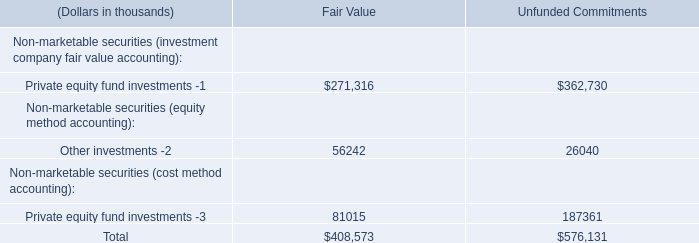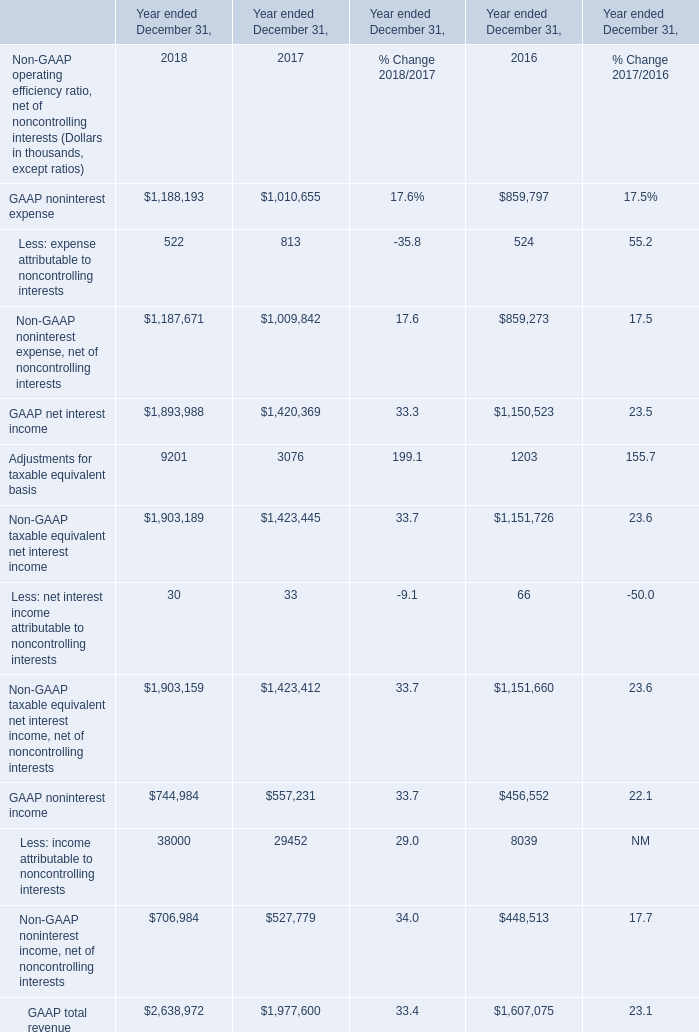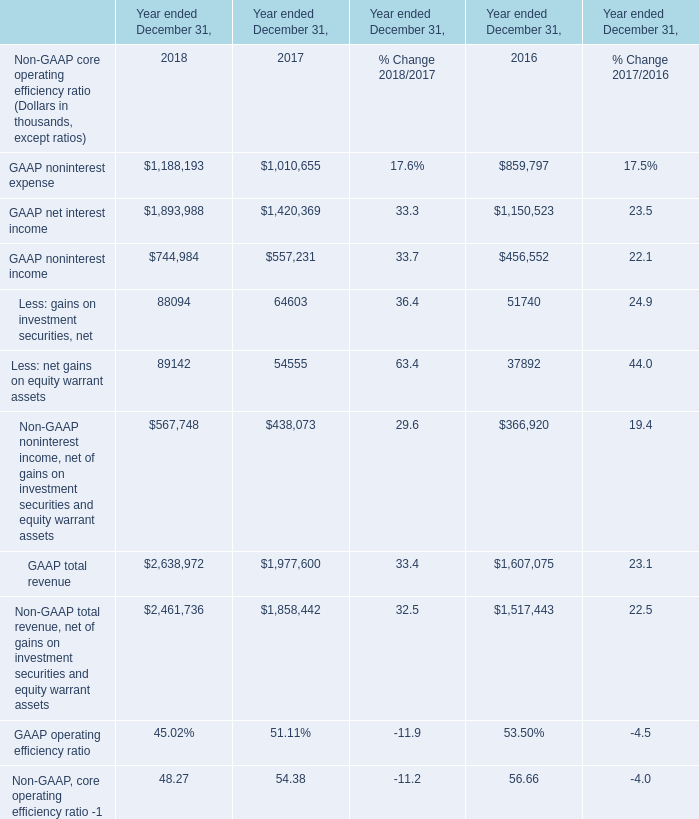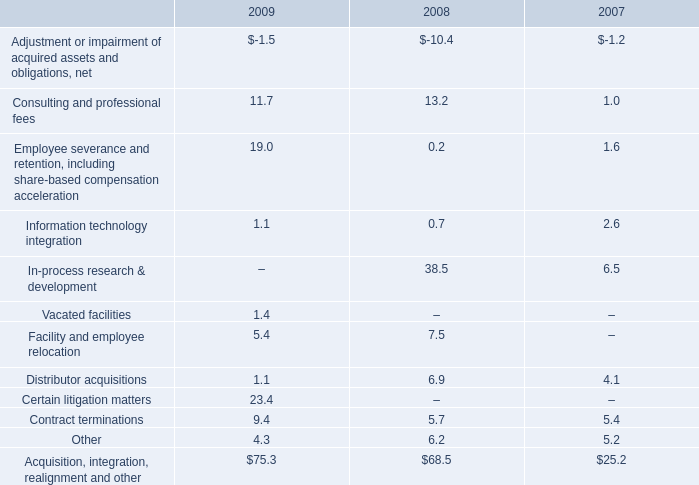What's the sum of GAAP net interest income of Year ended December 31, 2018, and GAAP net interest income of Year ended December 31, 2017 ? 
Computations: (1893988.0 + 1420369.0)
Answer: 3314357.0. 